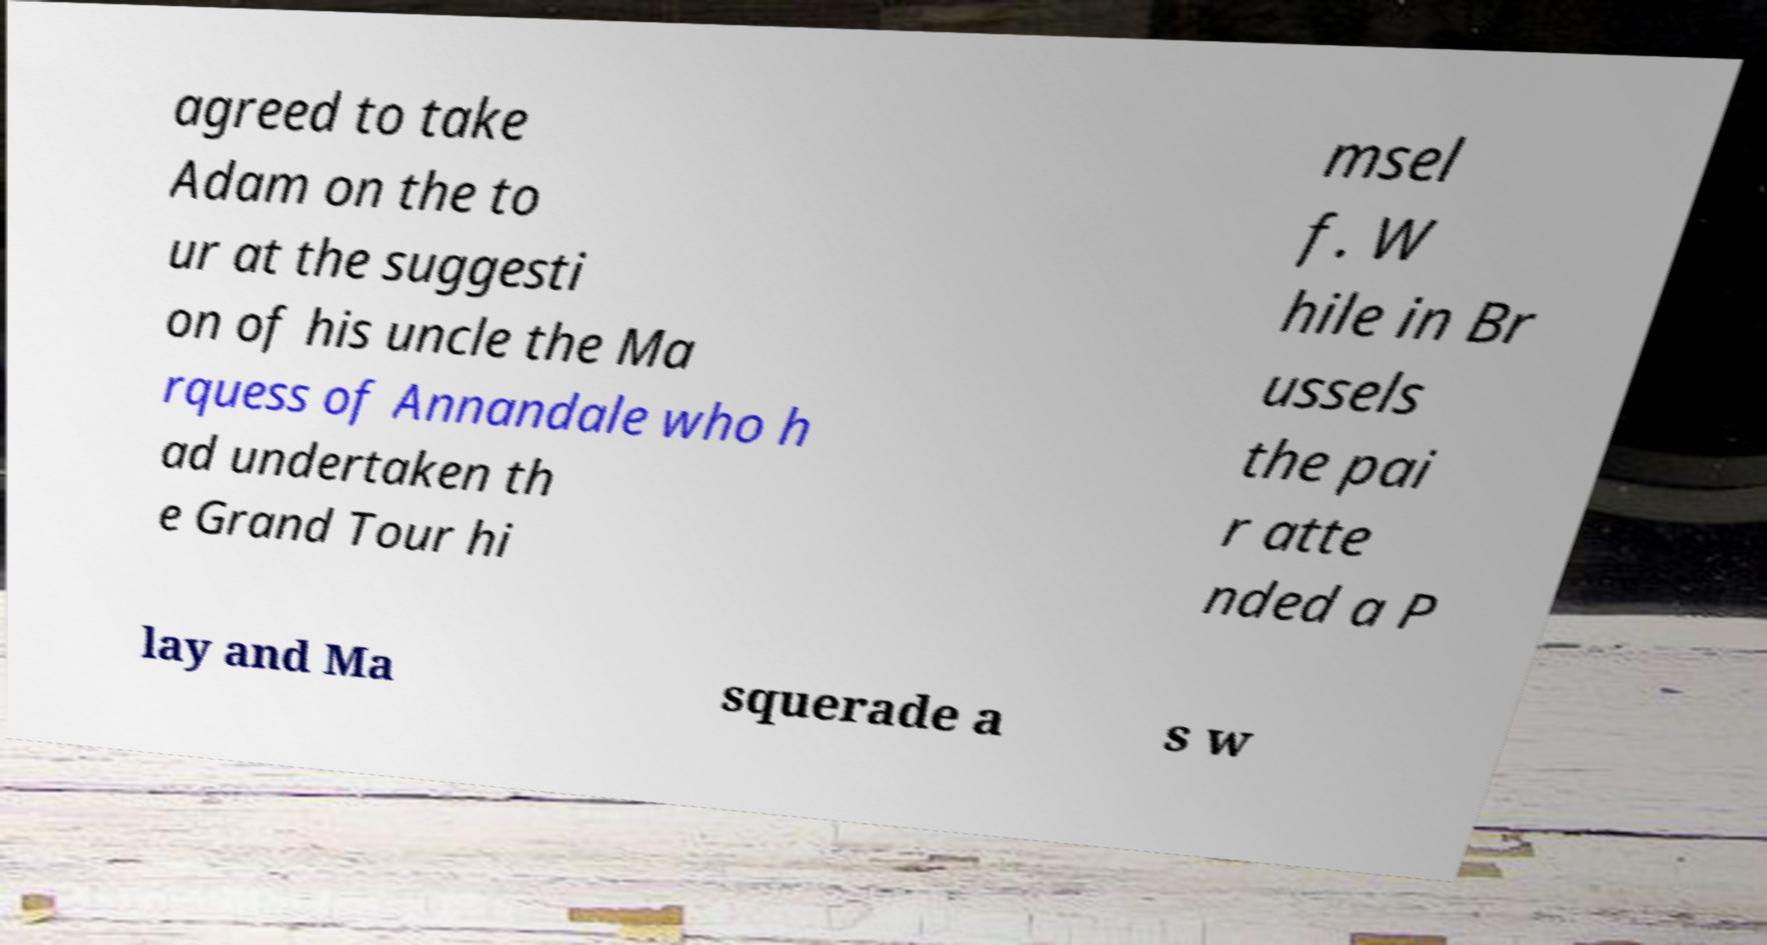Could you extract and type out the text from this image? agreed to take Adam on the to ur at the suggesti on of his uncle the Ma rquess of Annandale who h ad undertaken th e Grand Tour hi msel f. W hile in Br ussels the pai r atte nded a P lay and Ma squerade a s w 